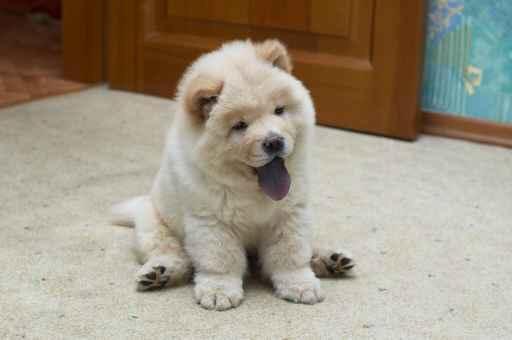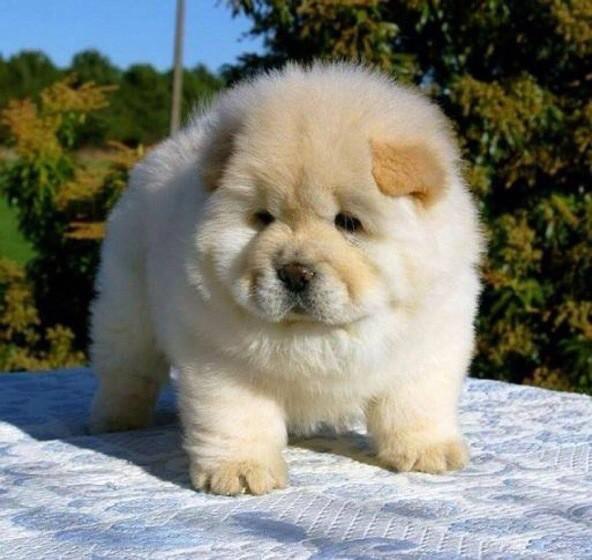The first image is the image on the left, the second image is the image on the right. Examine the images to the left and right. Is the description "The right image shows a chow eyeing the camera, with its head turned at a distinct angle." accurate? Answer yes or no. No. 